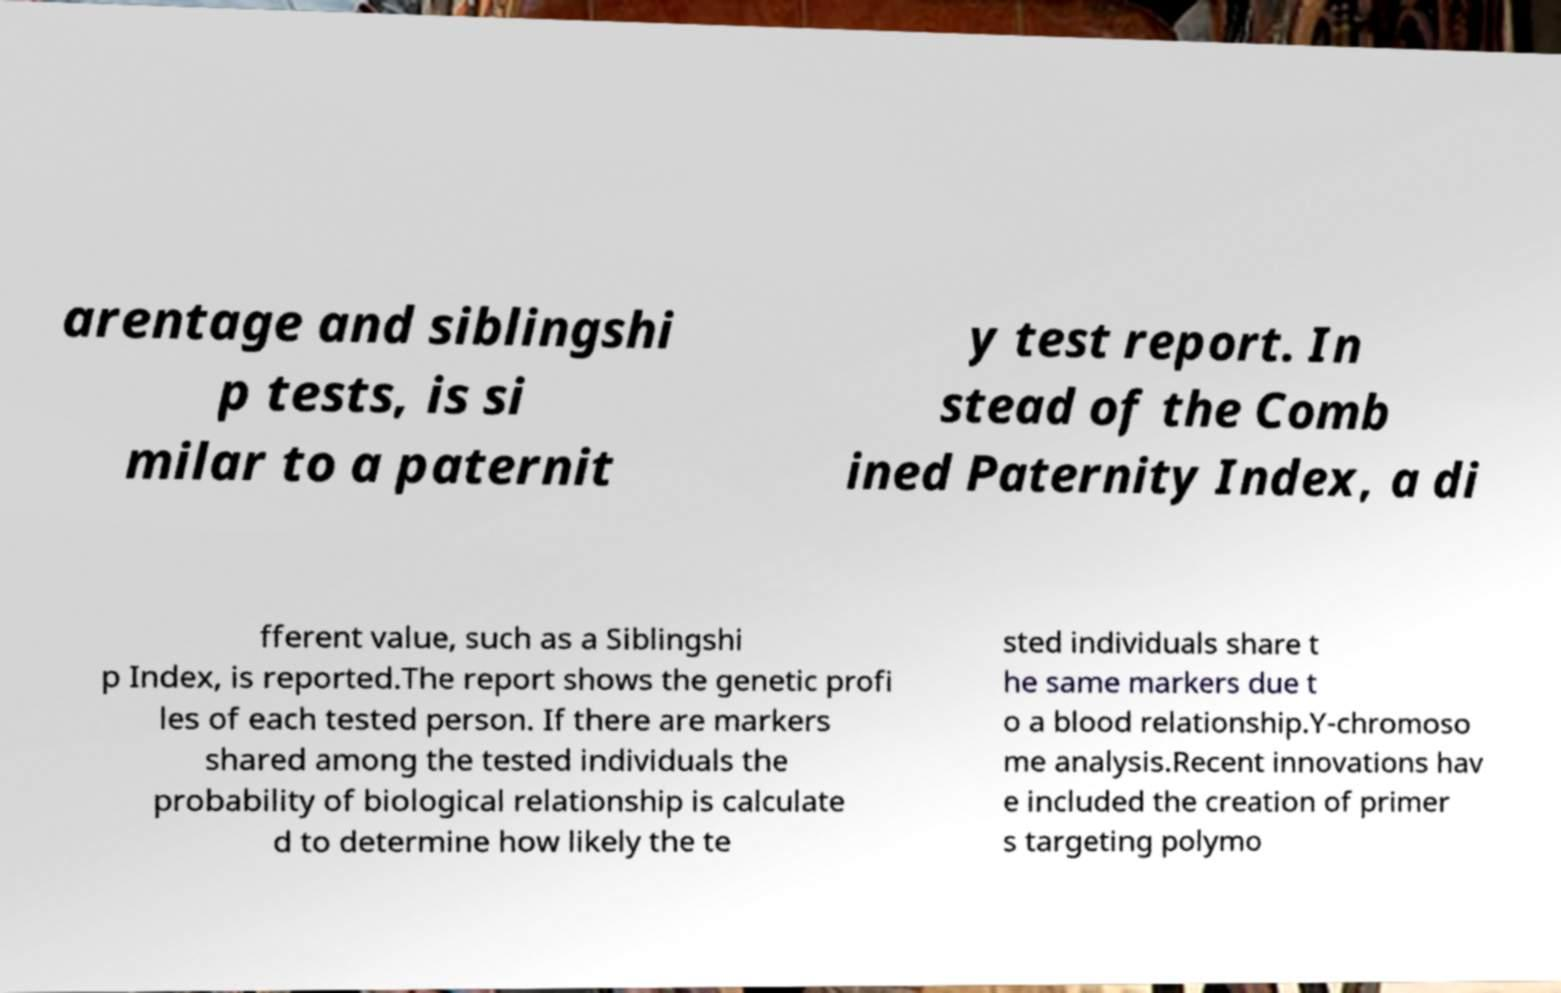Could you extract and type out the text from this image? arentage and siblingshi p tests, is si milar to a paternit y test report. In stead of the Comb ined Paternity Index, a di fferent value, such as a Siblingshi p Index, is reported.The report shows the genetic profi les of each tested person. If there are markers shared among the tested individuals the probability of biological relationship is calculate d to determine how likely the te sted individuals share t he same markers due t o a blood relationship.Y-chromoso me analysis.Recent innovations hav e included the creation of primer s targeting polymo 